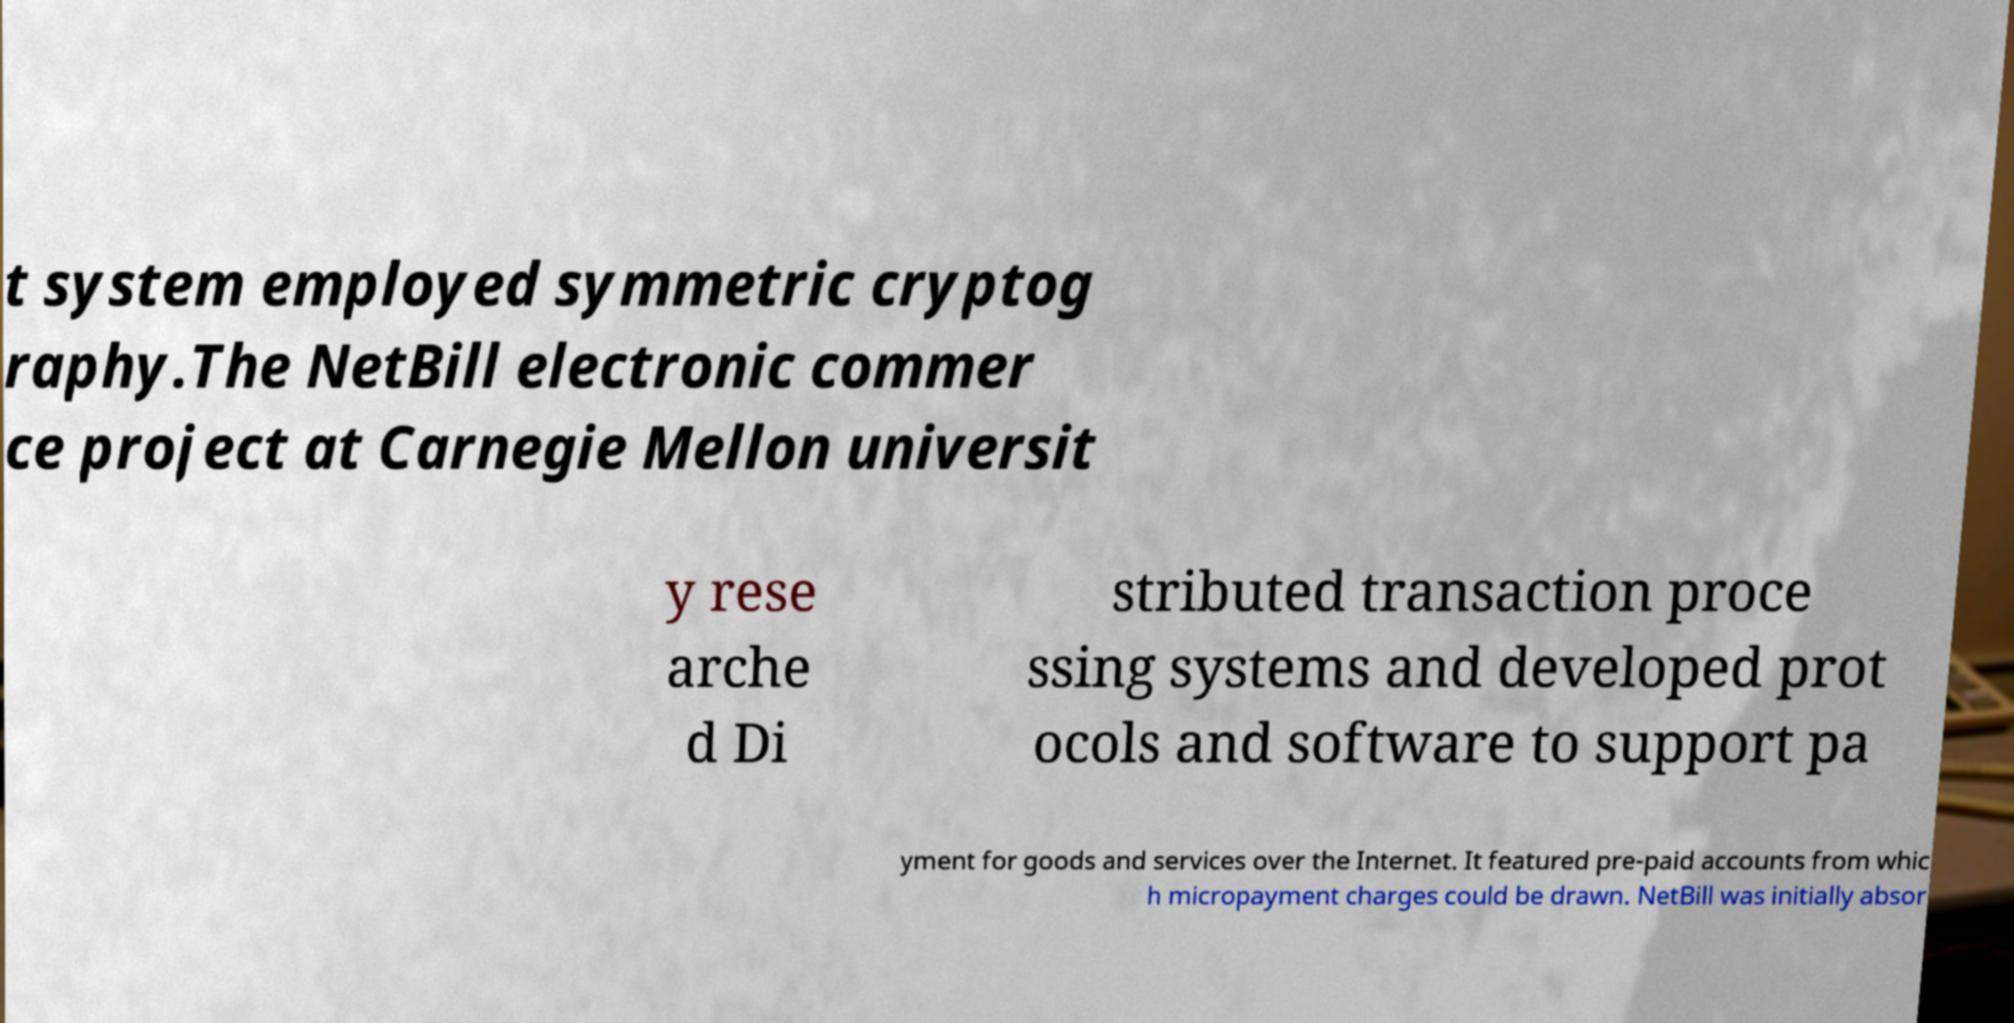Can you read and provide the text displayed in the image?This photo seems to have some interesting text. Can you extract and type it out for me? t system employed symmetric cryptog raphy.The NetBill electronic commer ce project at Carnegie Mellon universit y rese arche d Di stributed transaction proce ssing systems and developed prot ocols and software to support pa yment for goods and services over the Internet. It featured pre-paid accounts from whic h micropayment charges could be drawn. NetBill was initially absor 